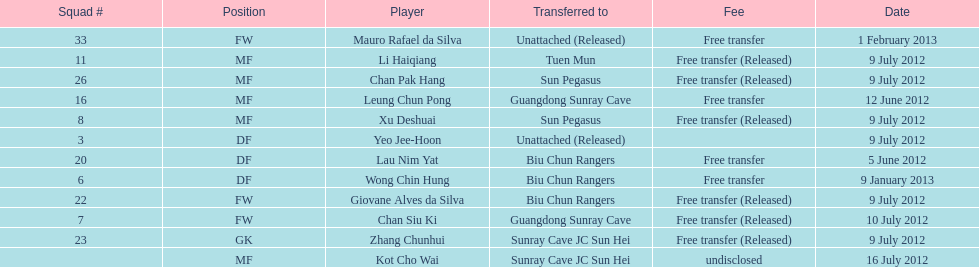What position is adjacent to squad #3? DF. 